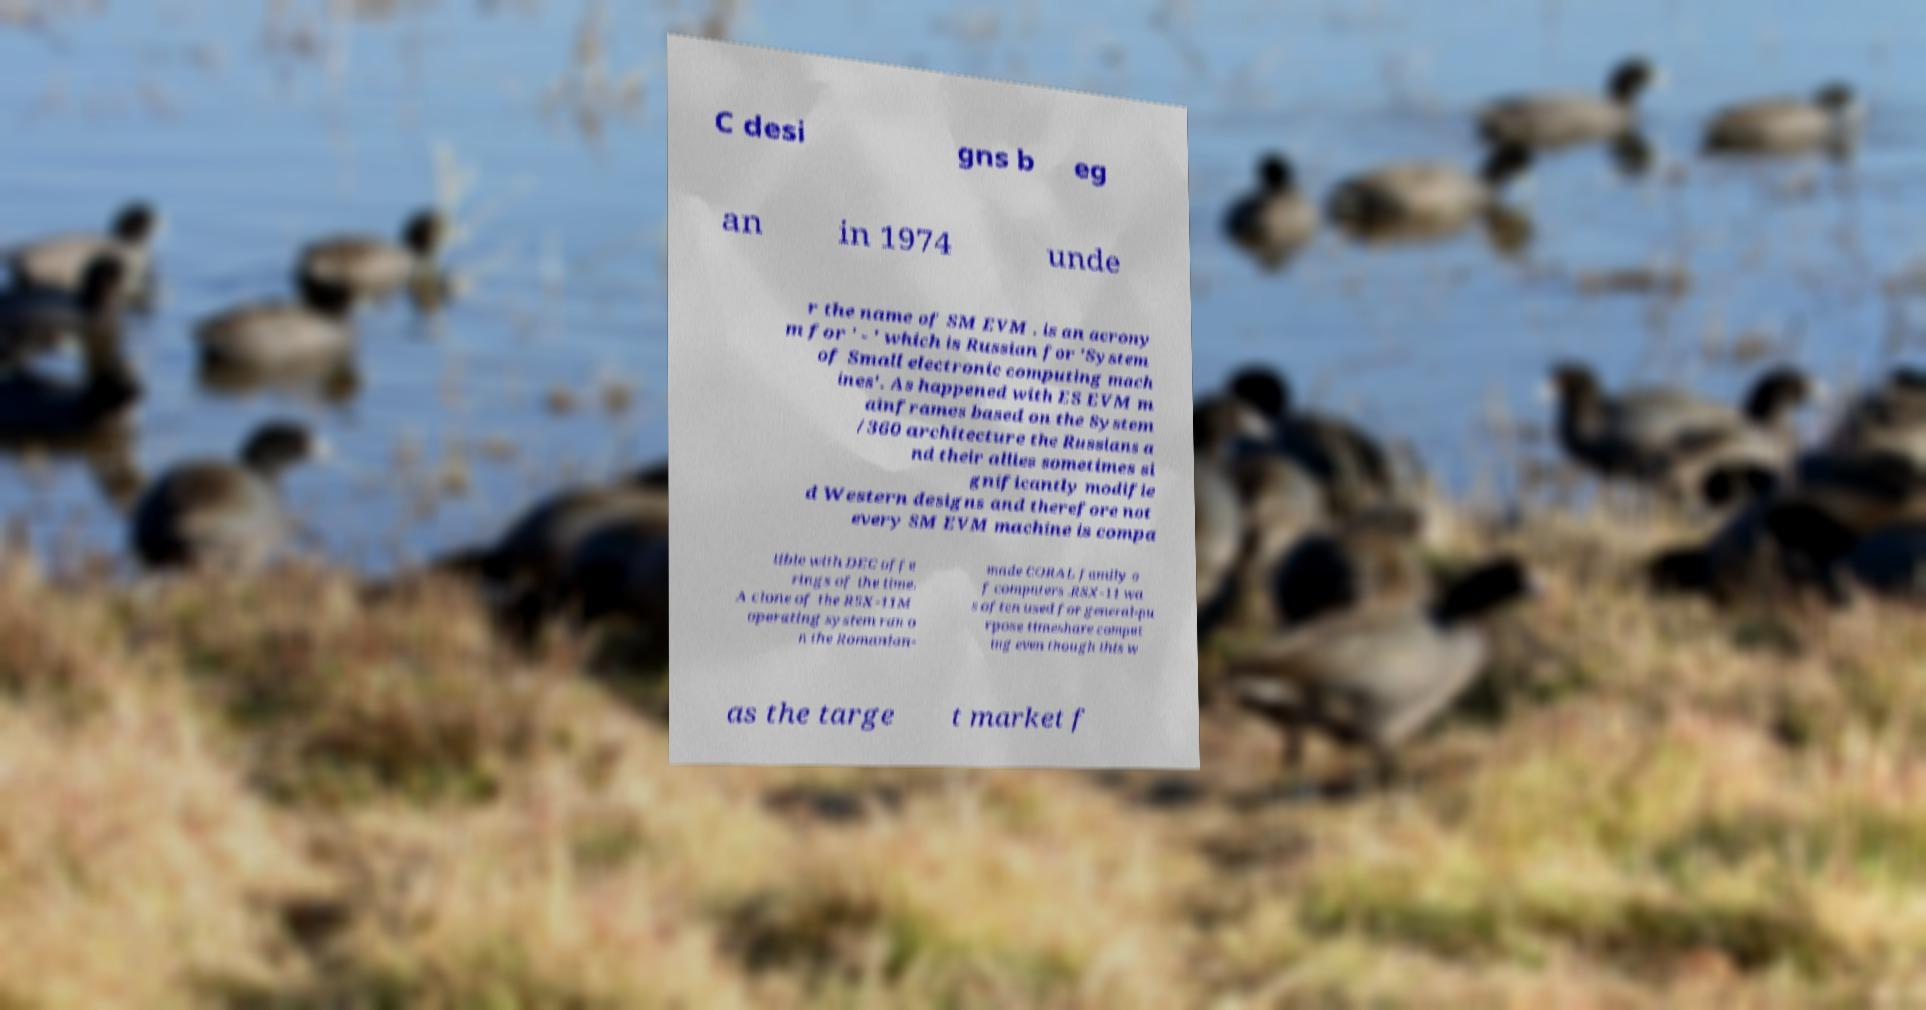Could you assist in decoding the text presented in this image and type it out clearly? C desi gns b eg an in 1974 unde r the name of SM EVM . is an acrony m for ' - ' which is Russian for 'System of Small electronic computing mach ines'. As happened with ES EVM m ainframes based on the System /360 architecture the Russians a nd their allies sometimes si gnificantly modifie d Western designs and therefore not every SM EVM machine is compa tible with DEC offe rings of the time. A clone of the RSX-11M operating system ran o n the Romanian- made CORAL family o f computers .RSX-11 wa s often used for general-pu rpose timeshare comput ing even though this w as the targe t market f 